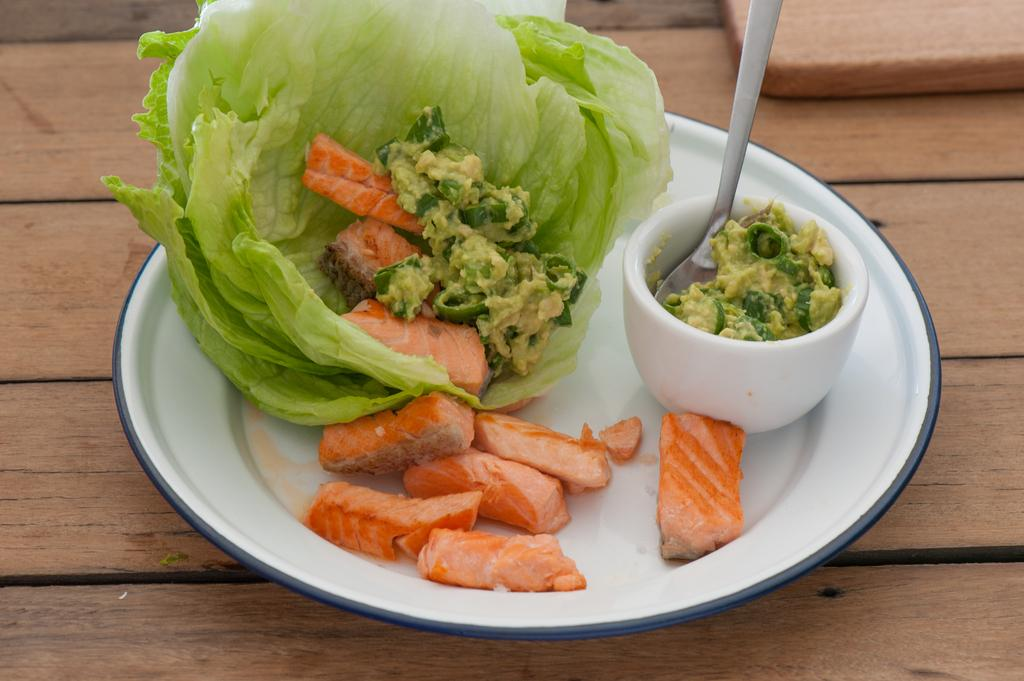What type of table is in the image? There is a wooden table in the image. What is on the table? There is a white color plate on the table, which contains vegetable salads. Is there anything else on the table besides the plate? Yes, there is a small bowl on the table, which contains curry. How can the curry be eaten? A spoon is present in the bowl, which can be used to eat the curry. What type of bed can be seen in the image? There is no bed present in the image; it features a wooden table with a plate, bowl, and spoon. Can you see any fangs on the vegetables in the salad? There are no fangs present on the vegetables in the salad; they are simply vegetables in a salad. 